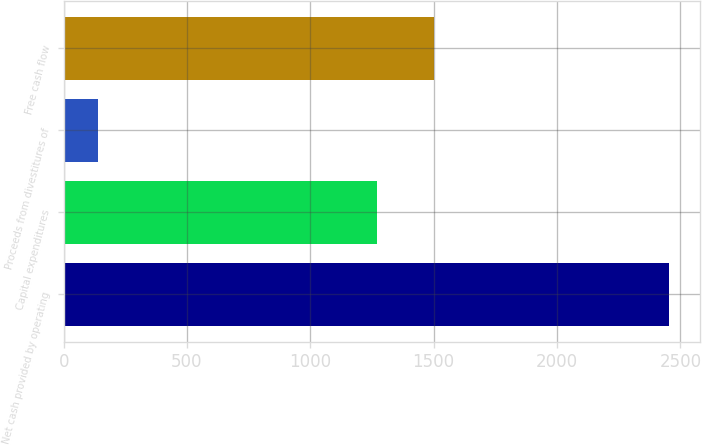Convert chart. <chart><loc_0><loc_0><loc_500><loc_500><bar_chart><fcel>Net cash provided by operating<fcel>Capital expenditures<fcel>Proceeds from divestitures of<fcel>Free cash flow<nl><fcel>2455<fcel>1271<fcel>138<fcel>1502.7<nl></chart> 